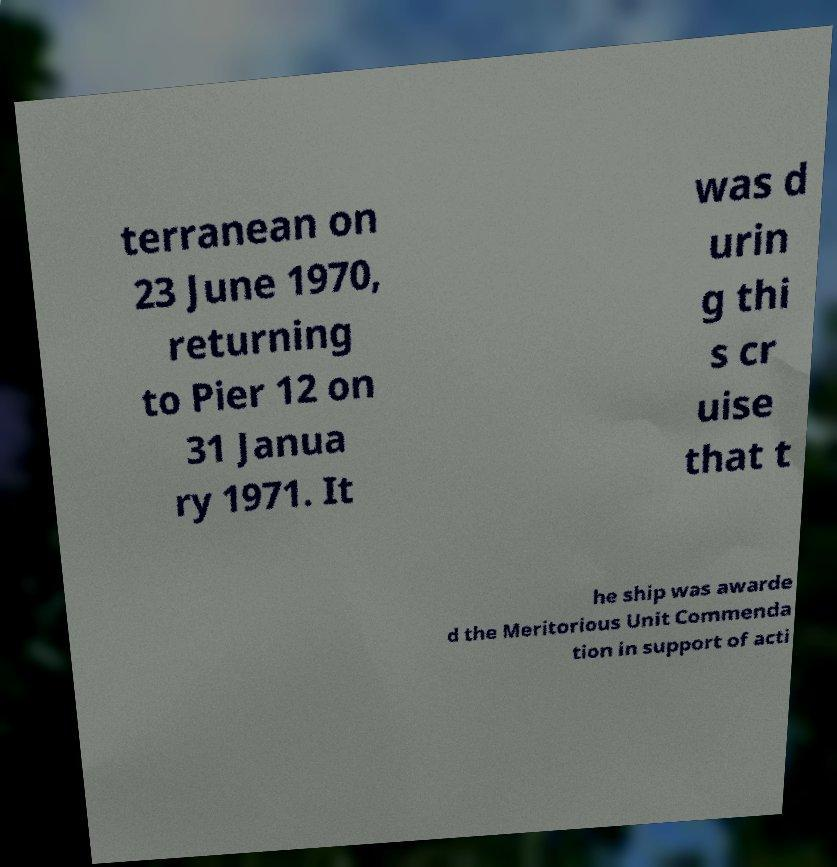Can you accurately transcribe the text from the provided image for me? terranean on 23 June 1970, returning to Pier 12 on 31 Janua ry 1971. It was d urin g thi s cr uise that t he ship was awarde d the Meritorious Unit Commenda tion in support of acti 